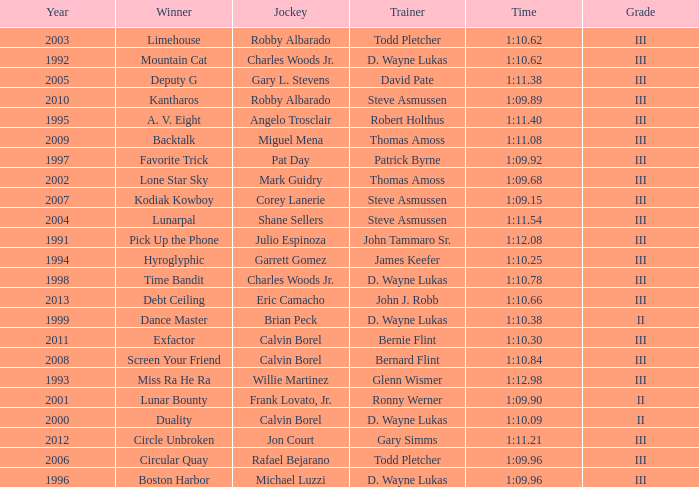Which trainer had a time of 1:10.09 with a year less than 2009? D. Wayne Lukas. 